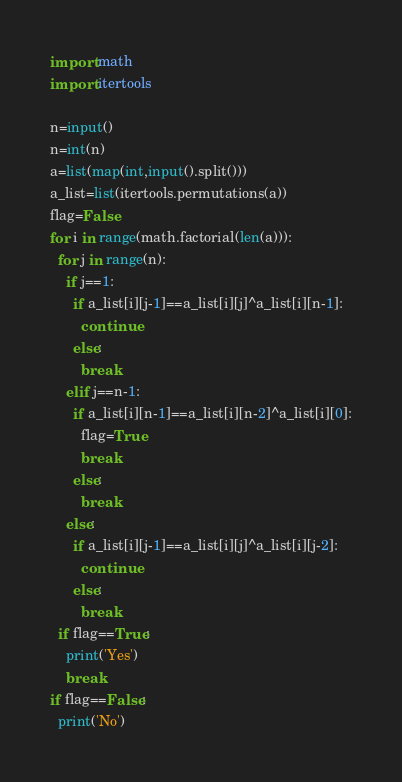<code> <loc_0><loc_0><loc_500><loc_500><_Python_>import math
import itertools

n=input()
n=int(n)
a=list(map(int,input().split()))
a_list=list(itertools.permutations(a))
flag=False
for i in range(math.factorial(len(a))):
  for j in range(n):
    if j==1:
      if a_list[i][j-1]==a_list[i][j]^a_list[i][n-1]:
        continue
      else:
        break
    elif j==n-1:
      if a_list[i][n-1]==a_list[i][n-2]^a_list[i][0]:
        flag=True
        break
      else:
        break
    else:
      if a_list[i][j-1]==a_list[i][j]^a_list[i][j-2]:
        continue
      else:
        break
  if flag==True:
    print('Yes')
    break
if flag==False:
  print('No')</code> 